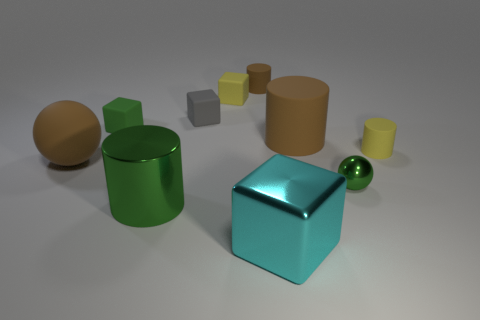How many tiny rubber things have the same color as the big ball?
Provide a short and direct response. 1. There is a big rubber object on the right side of the large cyan cube; does it have the same color as the large rubber sphere?
Your answer should be compact. Yes. What color is the big cylinder that is in front of the tiny yellow cylinder?
Keep it short and to the point. Green. Are there the same number of tiny metallic balls behind the yellow matte block and tiny green rubber things?
Provide a succinct answer. No. What number of other things are there of the same shape as the cyan metal thing?
Give a very brief answer. 3. How many green cylinders are right of the large green object?
Your answer should be very brief. 0. There is a cube that is to the right of the tiny gray rubber object and behind the big cyan object; how big is it?
Provide a succinct answer. Small. Are there any brown spheres?
Make the answer very short. Yes. How many other objects are there of the same size as the yellow matte cylinder?
Give a very brief answer. 5. Does the big metal thing that is left of the yellow cube have the same color as the sphere on the right side of the tiny brown thing?
Your answer should be very brief. Yes. 